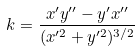Convert formula to latex. <formula><loc_0><loc_0><loc_500><loc_500>k = \frac { x ^ { \prime } y ^ { \prime \prime } - y ^ { \prime } x ^ { \prime \prime } } { ( x ^ { \prime 2 } + y ^ { \prime 2 } ) ^ { 3 / 2 } }</formula> 